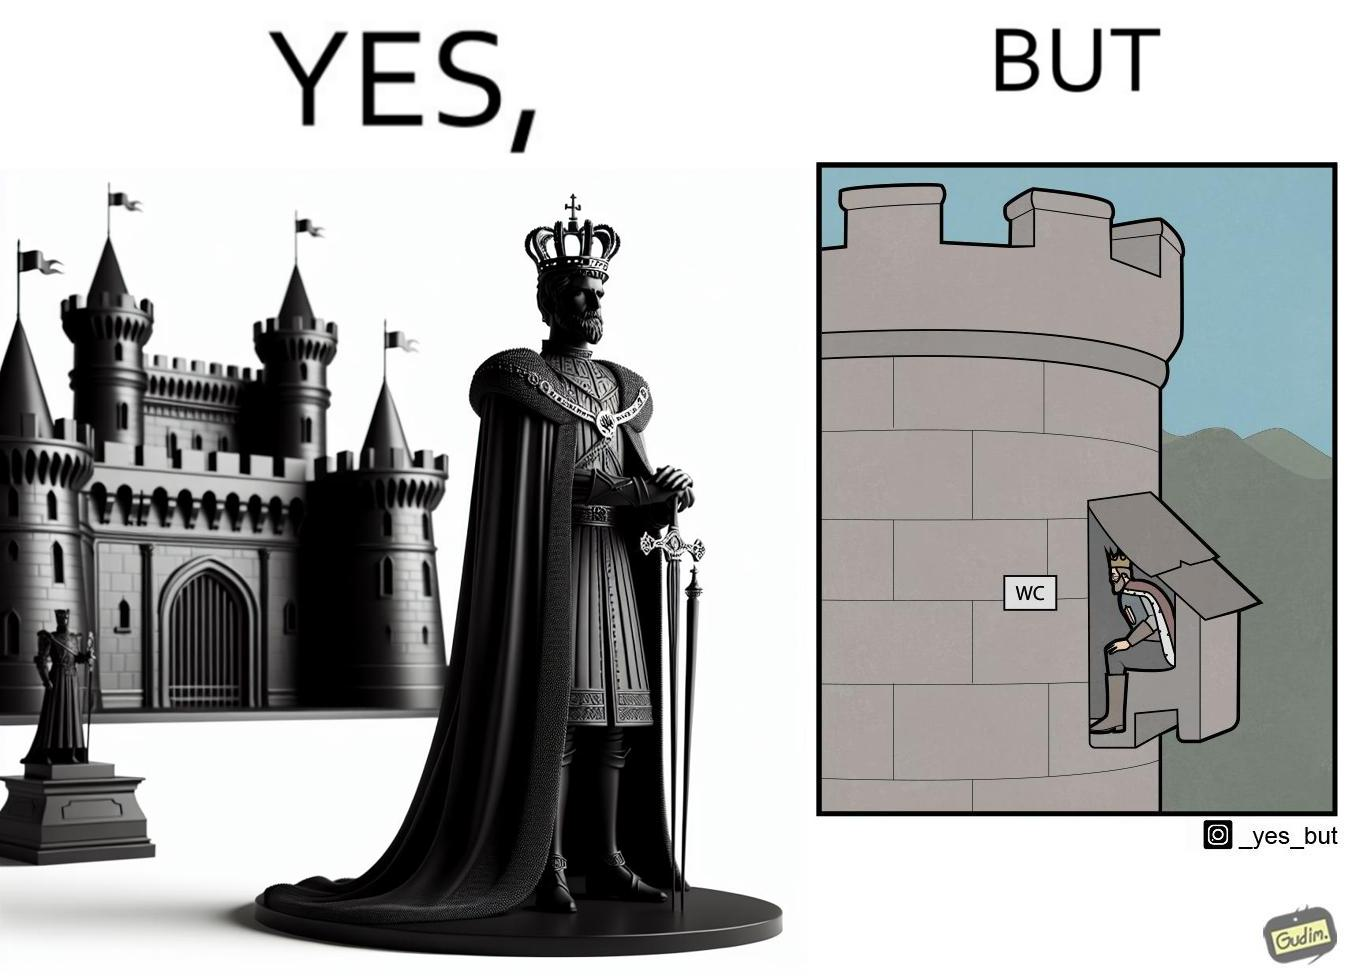What is shown in the left half versus the right half of this image? In the left part of the image: It is a mighty king in front of a castle In the right part of the image: It is a man using the toilet in a castle 